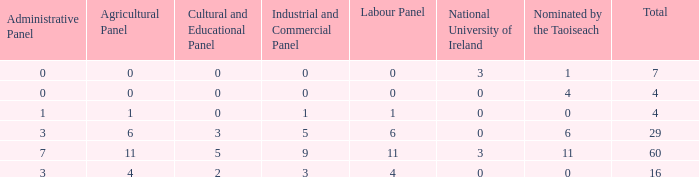What is the greatest number of nominations by taoiseach of the configuration with an administrative panel exceeding 0 and an industrial and commercial panel lesser than 1? None. 